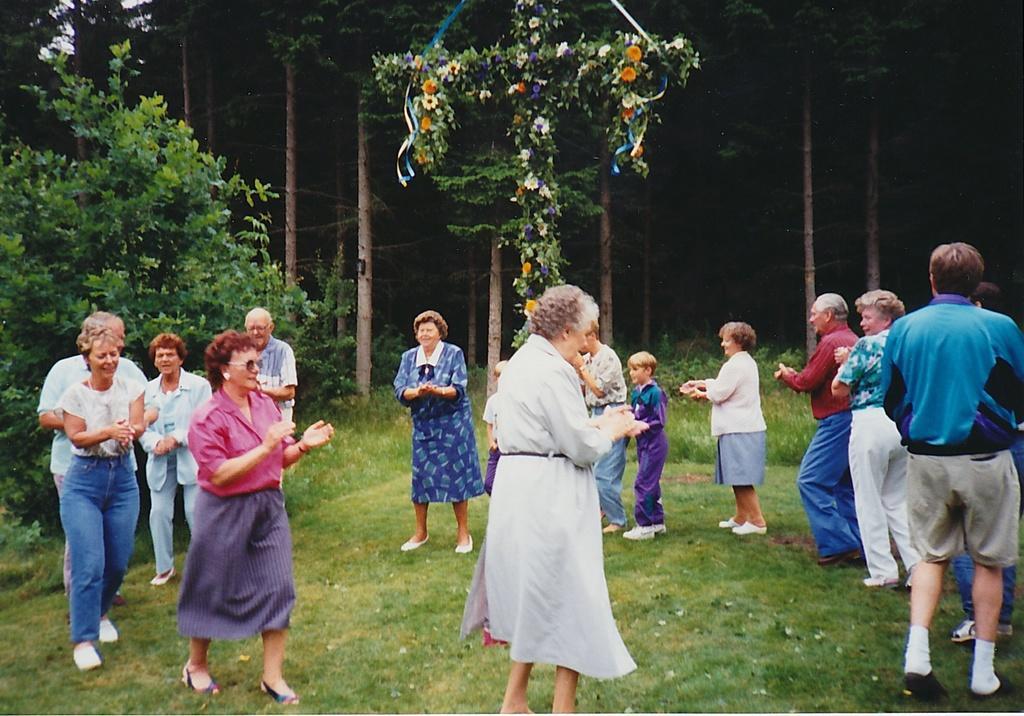In one or two sentences, can you explain what this image depicts? In this image we can see group of persons wearing dress are standing on the ground. One woman is wearing goggles. In the background, we can see a group of trees and the flowers. 